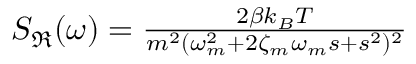Convert formula to latex. <formula><loc_0><loc_0><loc_500><loc_500>\begin{array} { r } { S _ { \Re } ( \omega ) = \frac { 2 \beta k _ { B } T } { m ^ { 2 } ( \omega _ { m } ^ { 2 } + 2 \zeta _ { m } \omega _ { m } s + s ^ { 2 } ) ^ { 2 } } } \end{array}</formula> 